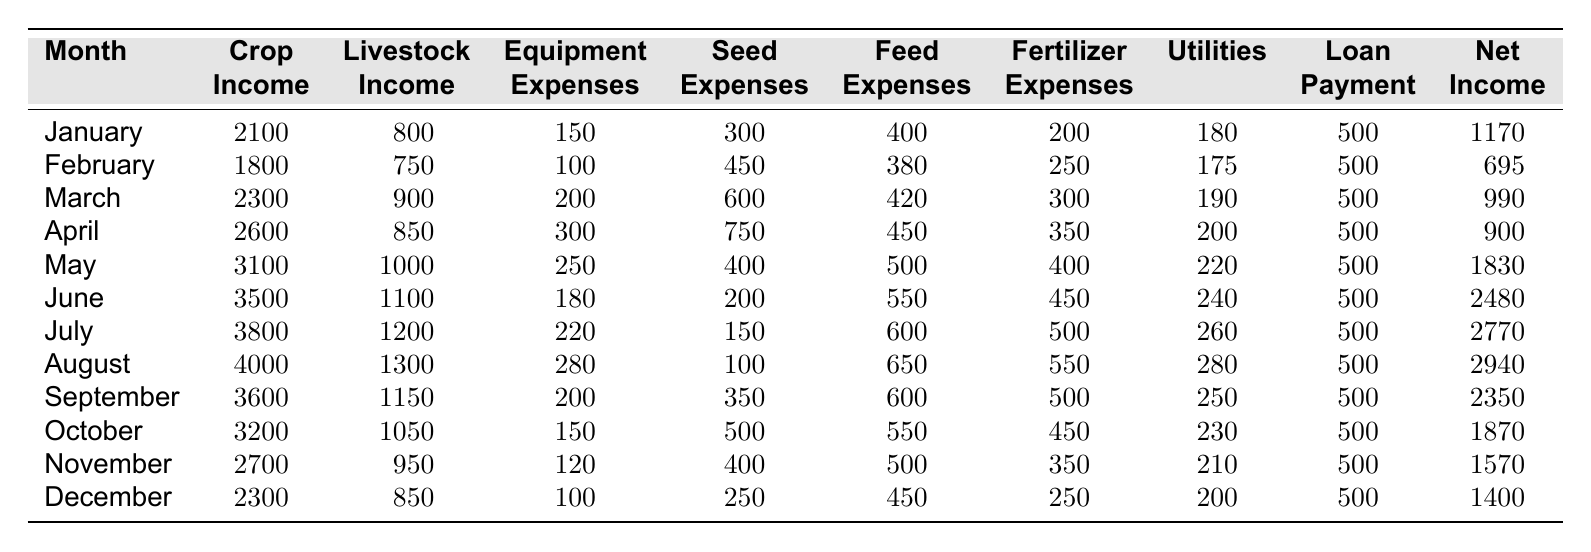What is the total crop income for the month of June? In June, the crop income is listed as 3500. Therefore, the total crop income for June is 3500.
Answer: 3500 What were the total expenses for the month of September? The expenses for September are Equipment (200), Seed (350), Feed (600), Fertilizer (500), Utilities (250), and Loan Payment (500). Adding these gives 200 + 350 + 600 + 500 + 250 + 500 = 2400.
Answer: 2400 What is the net income for the month of May? The net income for May is directly stated as 1830.
Answer: 1830 Was the total livestock income in August higher than in July? The livestock income in August is 1300 and in July it is 1200. Since 1300 > 1200, it is true that August's livestock income was higher than July's.
Answer: Yes What is the average crop income over the year? The crop incomes for the year are: 2100, 1800, 2300, 2600, 3100, 3500, 3800, 4000, 3600, 3200, 2700, 2300. Summing these gives 36,600. To find the average divide by 12, yielding 36,600 / 12 = 3050.
Answer: 3050 What month had the highest net income? The net incomes for the months are: 1170, 695, 990, 900, 1830, 2480, 2770, 2940, 2350, 1870, 1570, 1400. The highest net income is 2940, which occurs in August.
Answer: August Calculate the difference in net income between October and February. The net income for October is 1870 and for February it is 695. The difference is 1870 - 695 = 1175.
Answer: 1175 Is there a month where total expenses exceeded total incomes? To determine this, sum the total incomes and total expenses for each month. All months' net incomes (income - expenses) are positive, indicating no month had expenses exceeding incomes.
Answer: No What was the total livestock income for the second quarter (April to June)? The livestock incomes for April, May, and June are: 850, 1000, and 1100, respectively. Adding these gives 850 + 1000 + 1100 = 2950.
Answer: 2950 In which month was the loan payment the lowest? The loan payment is consistently listed as 500 for each month throughout the year; hence, there is no variation.
Answer: All months have the same loan payment 